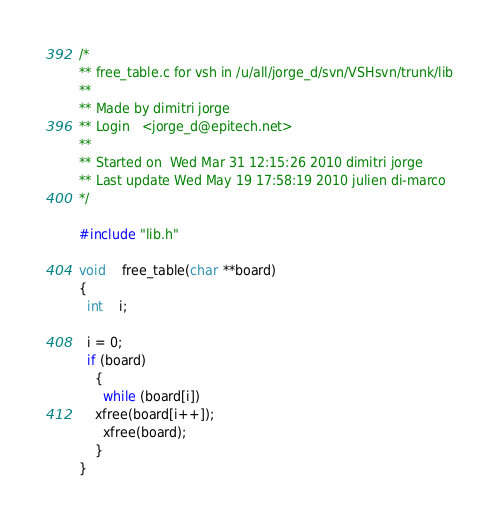Convert code to text. <code><loc_0><loc_0><loc_500><loc_500><_C_>/*
** free_table.c for vsh in /u/all/jorge_d/svn/VSHsvn/trunk/lib
** 
** Made by dimitri jorge
** Login   <jorge_d@epitech.net>
** 
** Started on  Wed Mar 31 12:15:26 2010 dimitri jorge
** Last update Wed May 19 17:58:19 2010 julien di-marco
*/

#include "lib.h"

void	free_table(char **board)
{
  int	i;

  i = 0;
  if (board)
    {
      while (board[i])
	xfree(board[i++]);
      xfree(board);
    }
}
</code> 